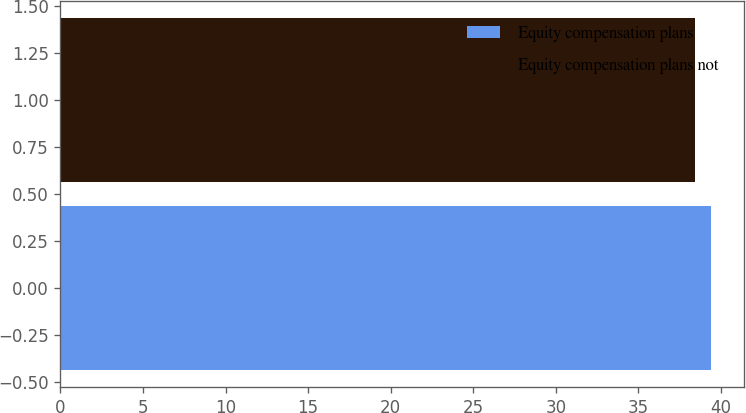Convert chart. <chart><loc_0><loc_0><loc_500><loc_500><bar_chart><fcel>Equity compensation plans<fcel>Equity compensation plans not<nl><fcel>39.42<fcel>38.42<nl></chart> 